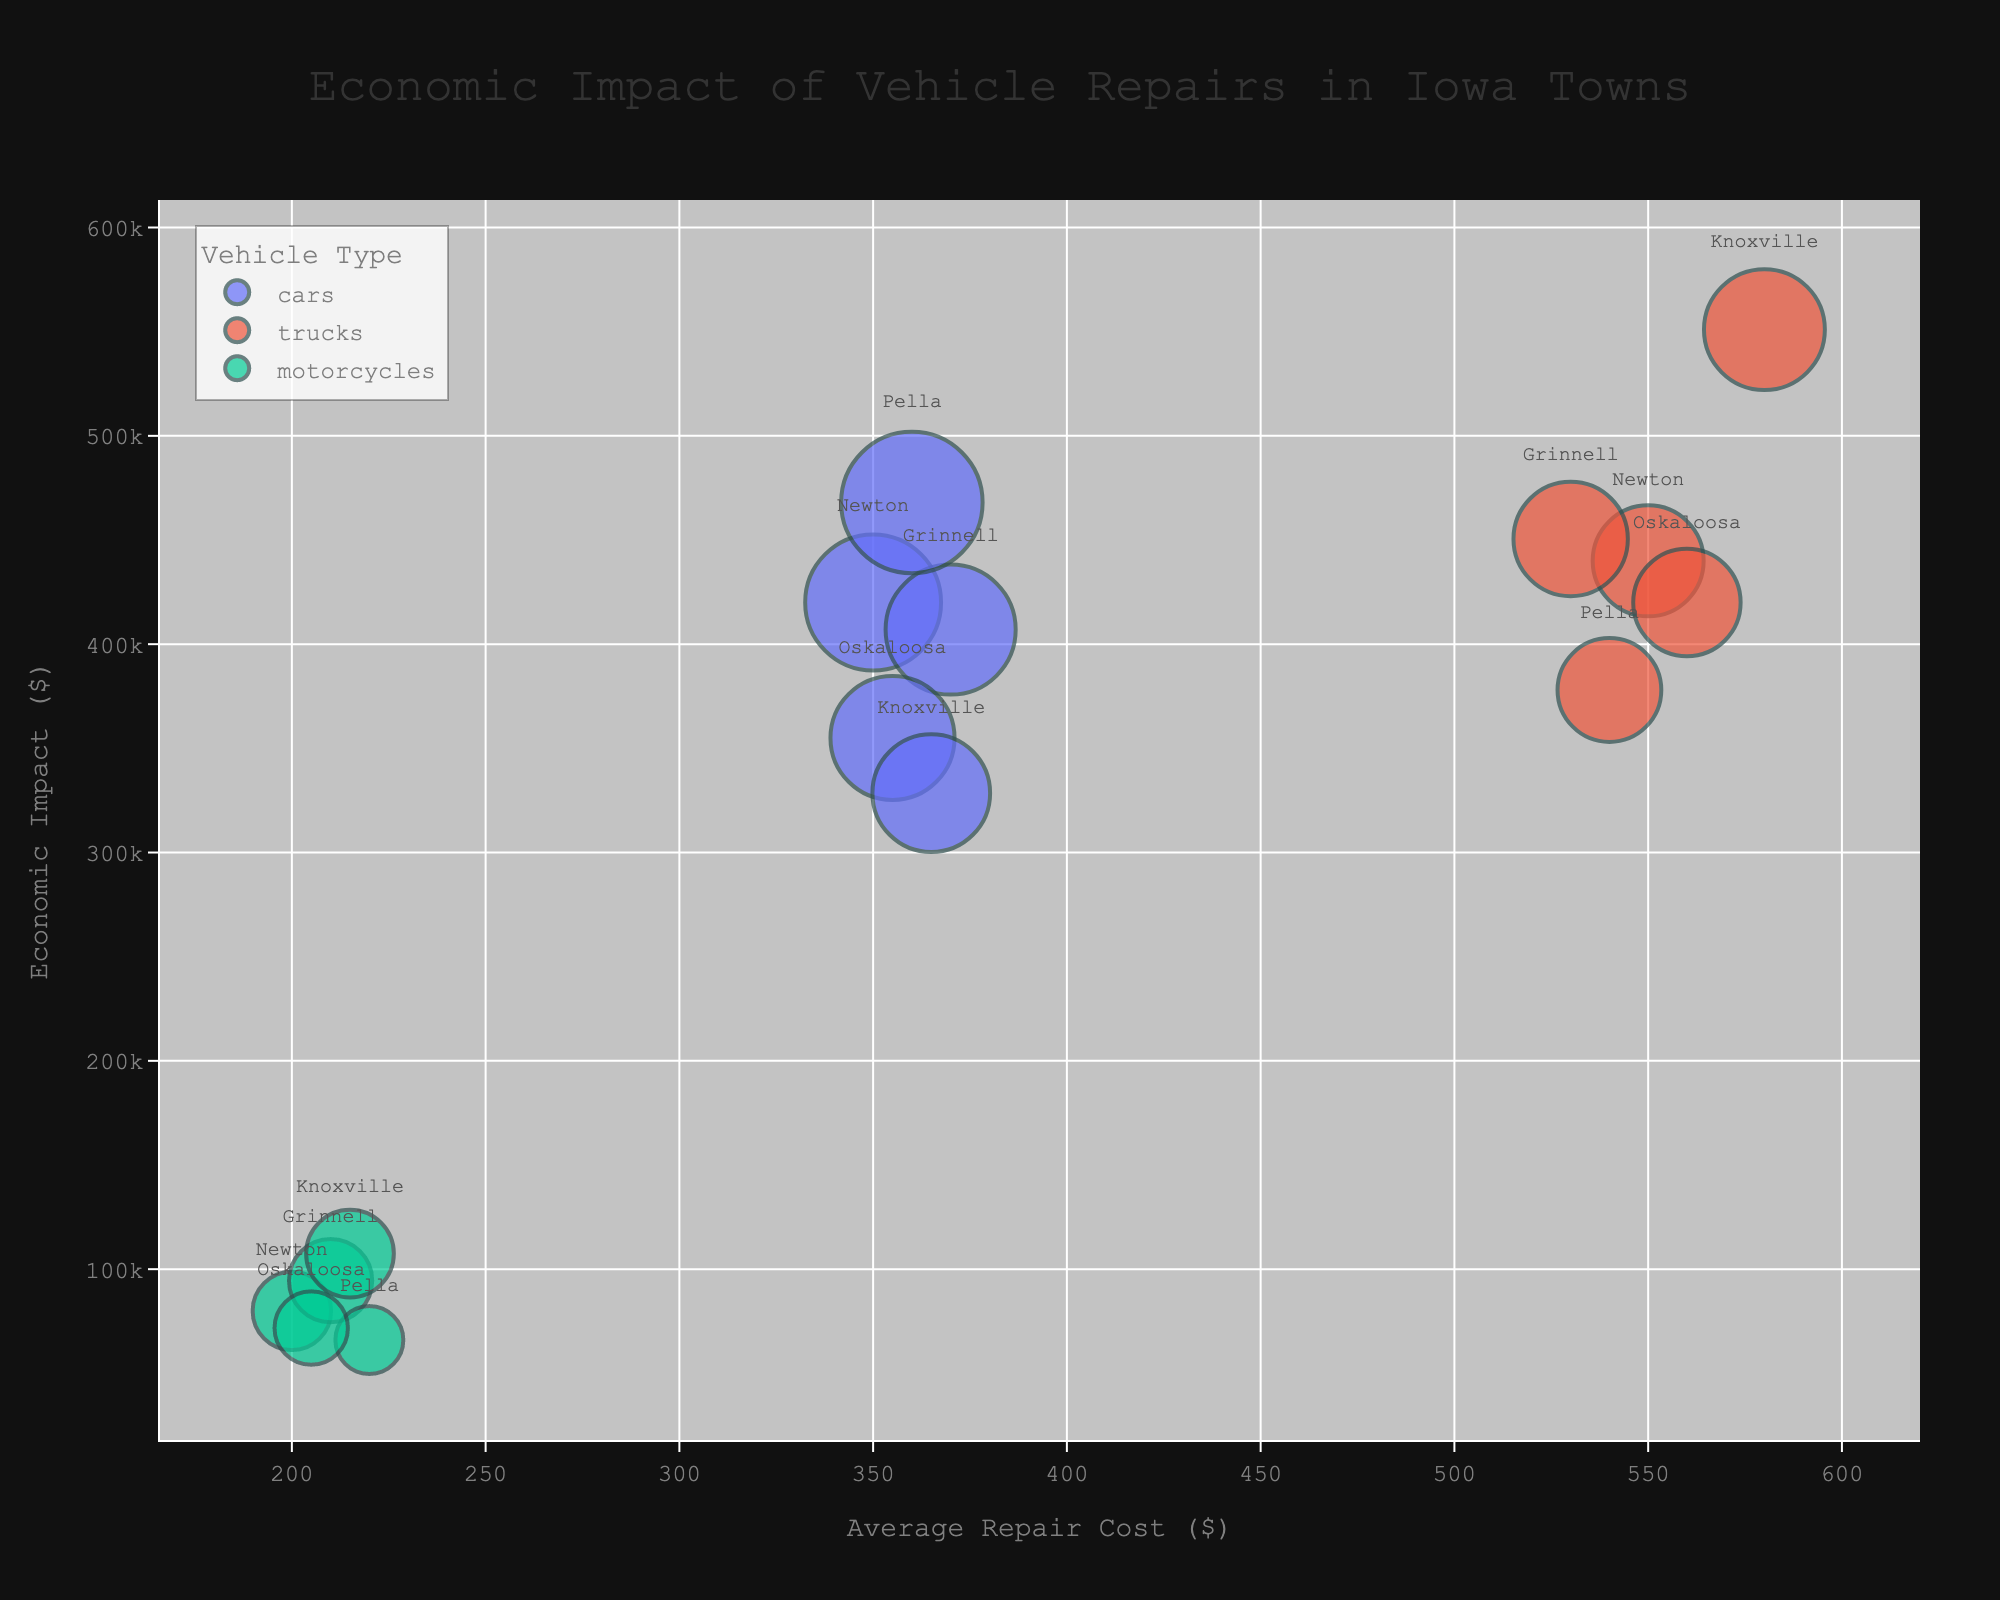What's the overall title of the figure? The title of the figure is usually written at the top of the chart. In this case, the title should be easy to see as "Economic Impact of Vehicle Repairs in Iowa Towns".
Answer: Economic Impact of Vehicle Repairs in Iowa Towns What are the labels on the x-axis and y-axis? The labels are usually displayed along the respective axes. Here, the x-axis is labeled "Average Repair Cost ($)" and the y-axis is labeled "Economic Impact ($)".
Answer: Average Repair Cost ($) and Economic Impact ($) Which vehicle type in Newton has the highest economic impact? To find this, look at the Newton data points and compare the 'economic_impact' values for cars, trucks, and motorcycles. The highest economic impact for Newton is 440,000 for trucks.
Answer: trucks Which town has the highest economic impact from motorcycle repairs? Identify the motorcycle data points and compare the 'economic_impact' values for each town. The highest economic impact from motorcycle repairs is in Grinnell with 94,500.
Answer: Grinnell What's the average repair cost of all vehicle types in Pella? Calculate the average repair cost of cars (360), trucks (540), and motorcycles (220) in Pella. The average is (360 + 540 + 220) / 3 = 373.33.
Answer: 373.33 Which town has the smallest bubble size for car repairs? The bubble size represents 'total_annual_repairs'. The smallest bubble for car repairs corresponds to the smallest total annual repairs, which is Knoxville with 900.
Answer: Knoxville In which town do motorcycles have the highest total annual repairs? Refer to the motorcycle data points and compare 'total_annual_repairs' values. The highest number is 500 in Knoxville.
Answer: Knoxville Compare the economic impact of car and truck repairs in Grinnell. Which is higher? The economic impact of car repairs in Grinnell is 407,000, while truck repairs sum to 450,500. Truck repairs have a higher economic impact.
Answer: Truck repairs Which vehicle type generally has the highest average repair costs? Compare the 'average_repair_cost' values for all 'type' categories. Trucks generally have the highest average repair costs.
Answer: Trucks What is the combined economic impact of truck repairs in Newton and Pella? Compute the sum of truck repairs' economic impact in Newton (440,000) and Pella (378,000), totaling 818,000.
Answer: 818,000 